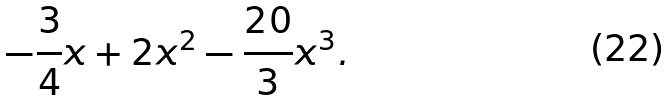Convert formula to latex. <formula><loc_0><loc_0><loc_500><loc_500>- \frac { 3 } { 4 } x + 2 x ^ { 2 } - \frac { 2 0 } { 3 } x ^ { 3 } .</formula> 